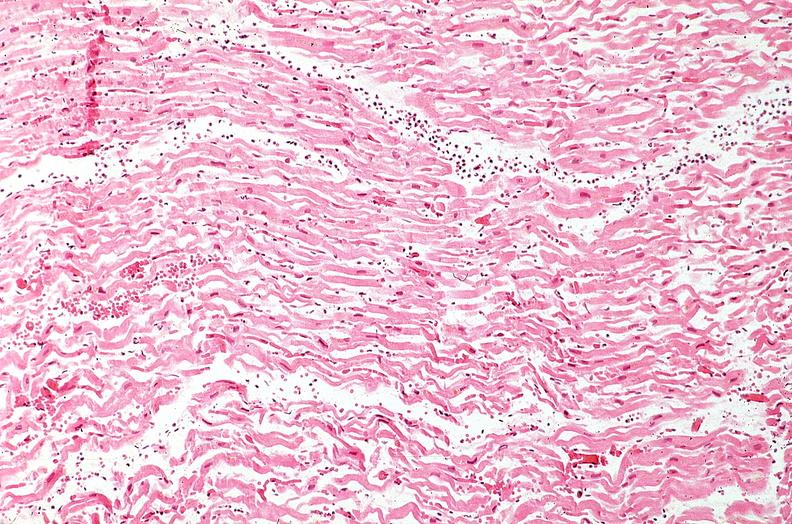where is this from?
Answer the question using a single word or phrase. Heart 